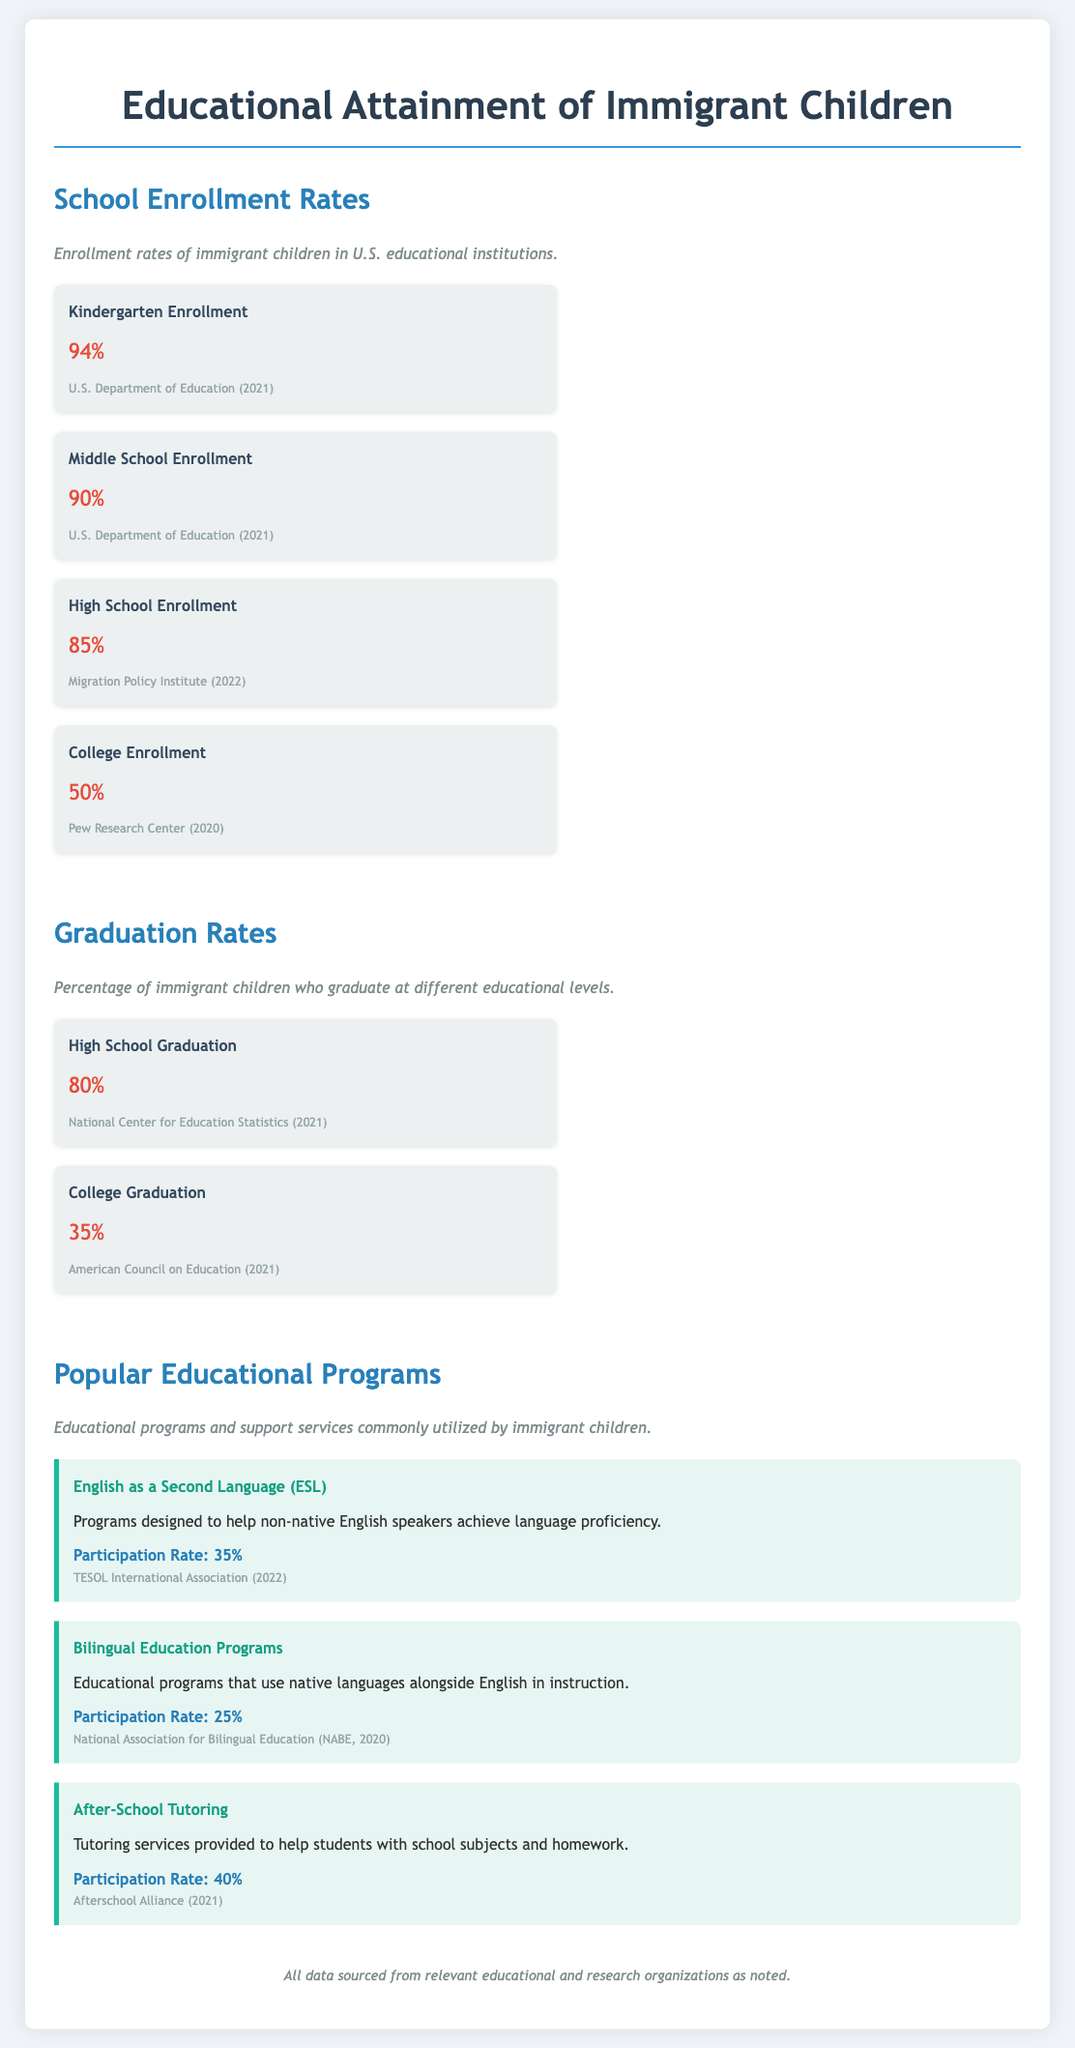What is the Kindergarten Enrollment rate? The document provides specific enrollment rates, and the Kindergarten Enrollment rate is mentioned as 94%.
Answer: 94% What percentage of immigrant children graduate high school? The document indicates the percentage of immigrant children who graduate high school as part of the graduation rates section.
Answer: 80% What is the participation rate for After-School Tutoring programs? The After-School Tutoring program is listed in the popular educational programs section, providing its participation rate.
Answer: 40% Which organization reported the College Graduation rate? The document lists sources for each statistic, and the College Graduation rate specifically cites the American Council on Education.
Answer: American Council on Education How many educational programs are highlighted in the document? The document lists three popular educational programs aimed at immigrant children, requiring a count from that section.
Answer: 3 What is the participation rate for Bilingual Education Programs? The document provides specific rates for educational programs, including Bilingual Education Programs.
Answer: 25% What percentage of immigrant children enroll in college? The document mentions the college enrollment rate specifically, allowing for a direct retrieval of that statistic.
Answer: 50% Which program has the highest participation rate? By comparing the participation rates listed in the document, I can identify which program has the highest rate.
Answer: After-School Tutoring 